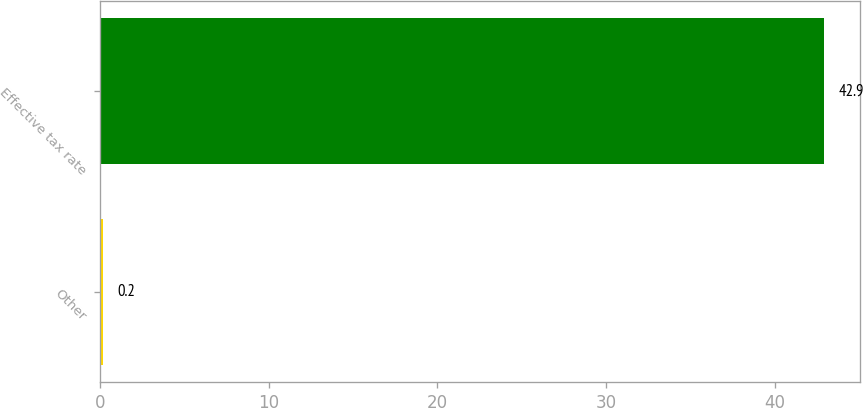Convert chart. <chart><loc_0><loc_0><loc_500><loc_500><bar_chart><fcel>Other<fcel>Effective tax rate<nl><fcel>0.2<fcel>42.9<nl></chart> 